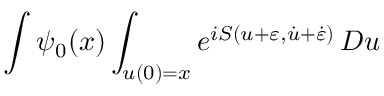<formula> <loc_0><loc_0><loc_500><loc_500>\int \psi _ { 0 } ( x ) \int _ { u ( 0 ) = x } e ^ { i S ( u + \varepsilon , { \dot { u } } + { \dot { \varepsilon } } ) } \, D u</formula> 